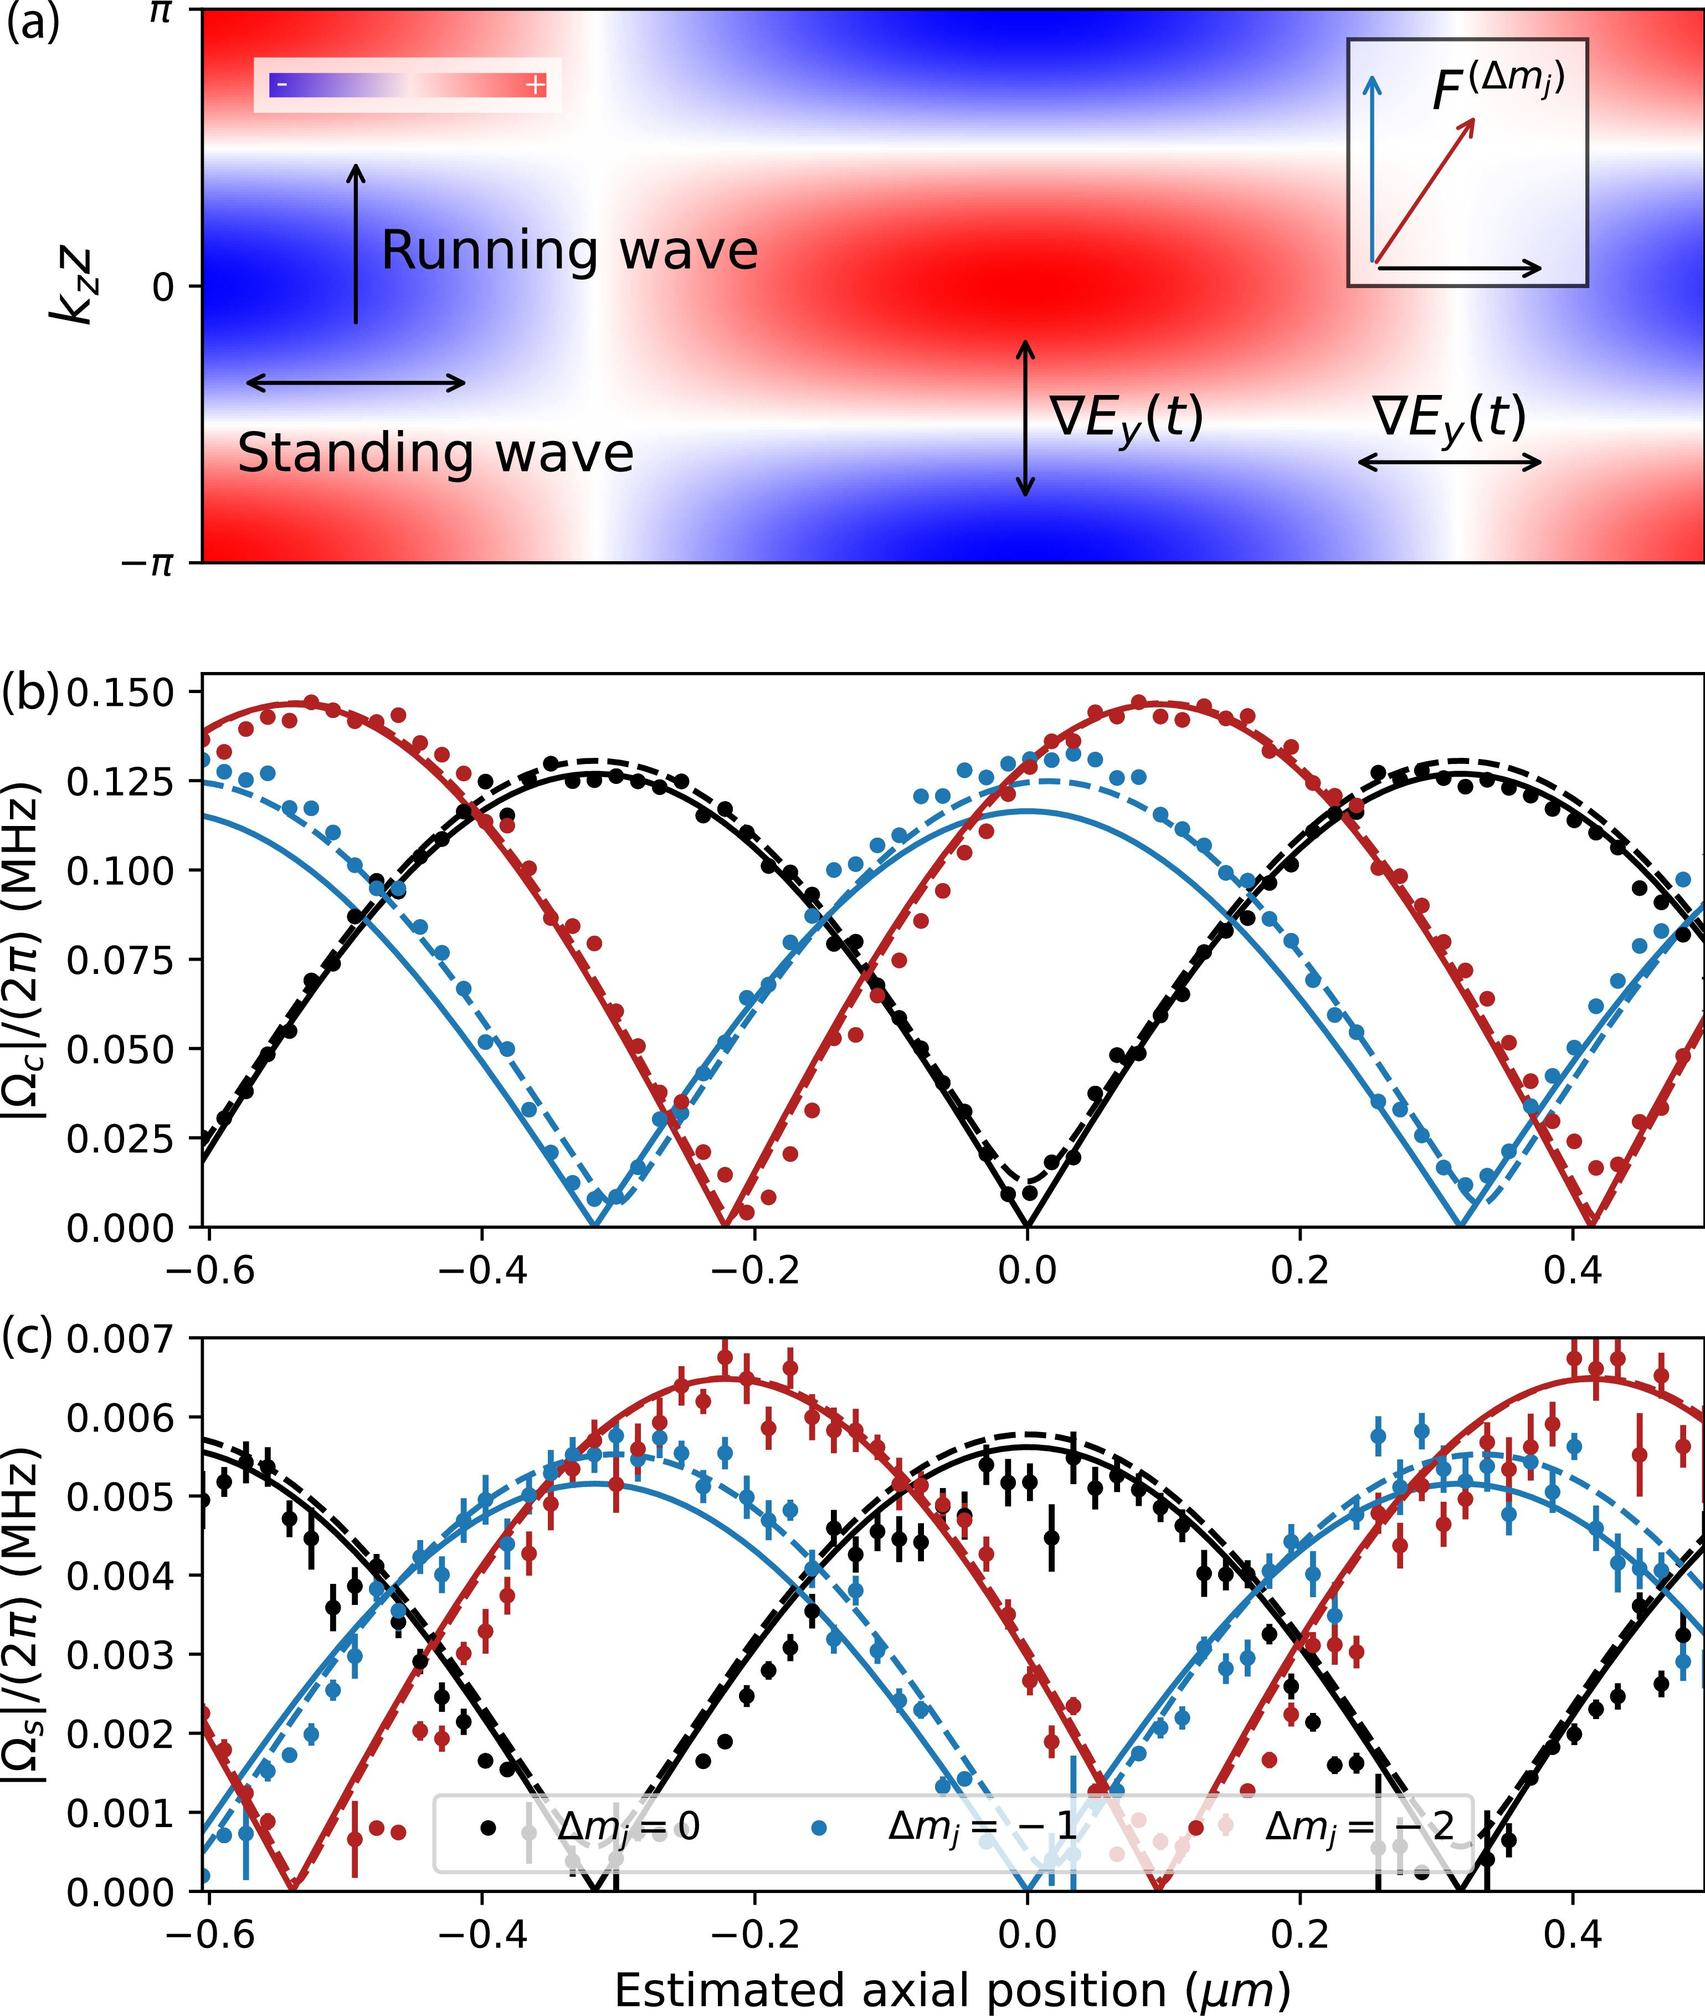Based on Figure (c), which \( \Delta m_j \) value corresponds to the largest variation in \( \Omega_S \) with respect to the estimated axial position? A. \( \Delta m_j = 0 \) B. \( \Delta m_j = -1 \) C. \( \Delta m_j = +2 \) D. \( \Delta m_j = +1 \) In Figure (c), observing the plotted curves clearly indicates that the red curve, representing \( \Delta m_j = +2 \), exhibits the most significant fluctuations, spanning the highest peaks and deepest troughs. This behavior signifies the largest variation in \( \Omega_S \). Thus, the most accurate answer is option C, \( \Delta m_j = +2 \), which corroborates the visible data presented in the graph form. 